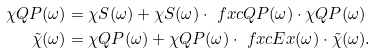<formula> <loc_0><loc_0><loc_500><loc_500>\chi Q P ( \omega ) & = \chi S ( \omega ) + \chi S ( \omega ) \cdot \ f x c Q P ( \omega ) \cdot \chi Q P ( \omega ) \\ \tilde { \chi } ( \omega ) & = \chi Q P ( \omega ) + \chi Q P ( \omega ) \cdot \ f x c E x ( \omega ) \cdot \tilde { \chi } ( \omega ) \text {.}</formula> 